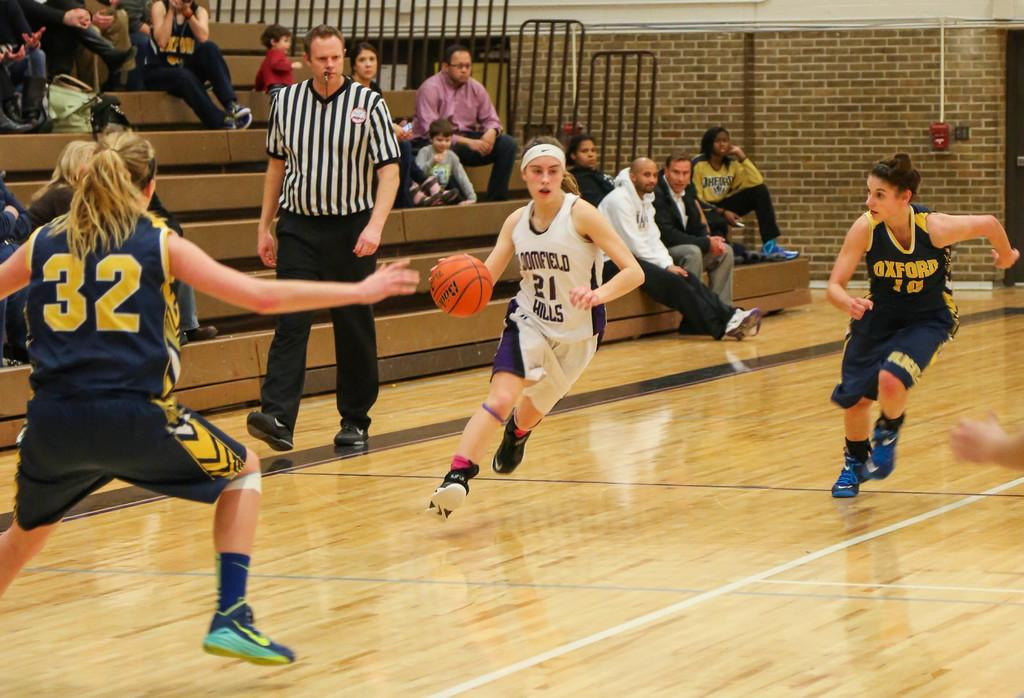Who or what can be seen in the image? There are people in the image. What is the background of the image? There is a wall in the image. Are there any architectural features present? Yes, there are stairs in the image. What object can be seen in addition to the people and architectural features? There is a ball in the image. What type of gun can be seen in the image? There is no gun present in the image. How does the image make you feel? The image itself does not evoke a specific feeling, as it is a static representation of people, a wall, stairs, and a ball. The feeling experienced by the viewer may vary depending on personal factors and context. 